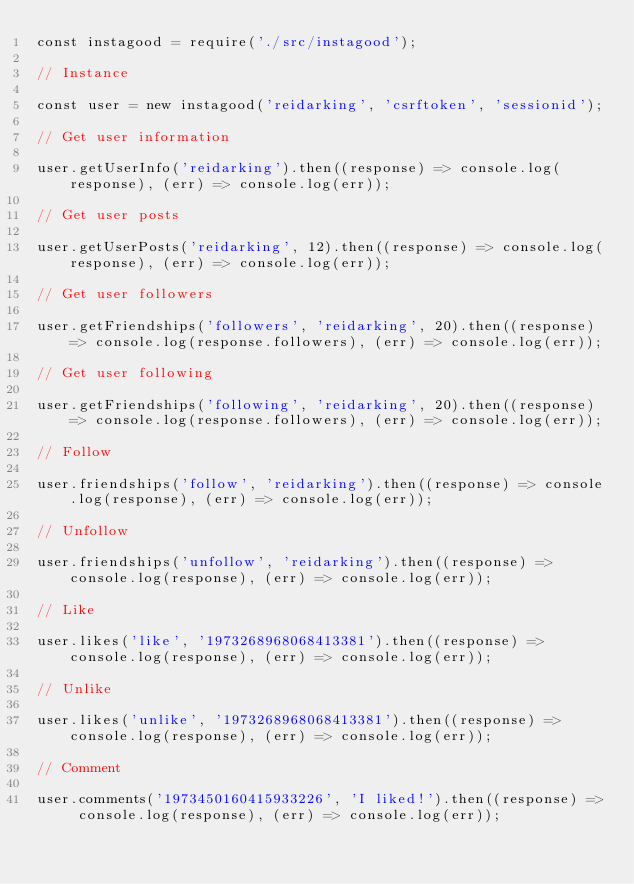<code> <loc_0><loc_0><loc_500><loc_500><_JavaScript_>const instagood = require('./src/instagood');

// Instance

const user = new instagood('reidarking', 'csrftoken', 'sessionid');

// Get user information

user.getUserInfo('reidarking').then((response) => console.log(response), (err) => console.log(err));

// Get user posts

user.getUserPosts('reidarking', 12).then((response) => console.log(response), (err) => console.log(err));

// Get user followers

user.getFriendships('followers', 'reidarking', 20).then((response) => console.log(response.followers), (err) => console.log(err));

// Get user following

user.getFriendships('following', 'reidarking', 20).then((response) => console.log(response.followers), (err) => console.log(err));

// Follow

user.friendships('follow', 'reidarking').then((response) => console.log(response), (err) => console.log(err));

// Unfollow

user.friendships('unfollow', 'reidarking').then((response) => console.log(response), (err) => console.log(err));

// Like

user.likes('like', '1973268968068413381').then((response) => console.log(response), (err) => console.log(err));

// Unlike

user.likes('unlike', '1973268968068413381').then((response) => console.log(response), (err) => console.log(err));

// Comment

user.comments('1973450160415933226', 'I liked!').then((response) => console.log(response), (err) => console.log(err));
</code> 